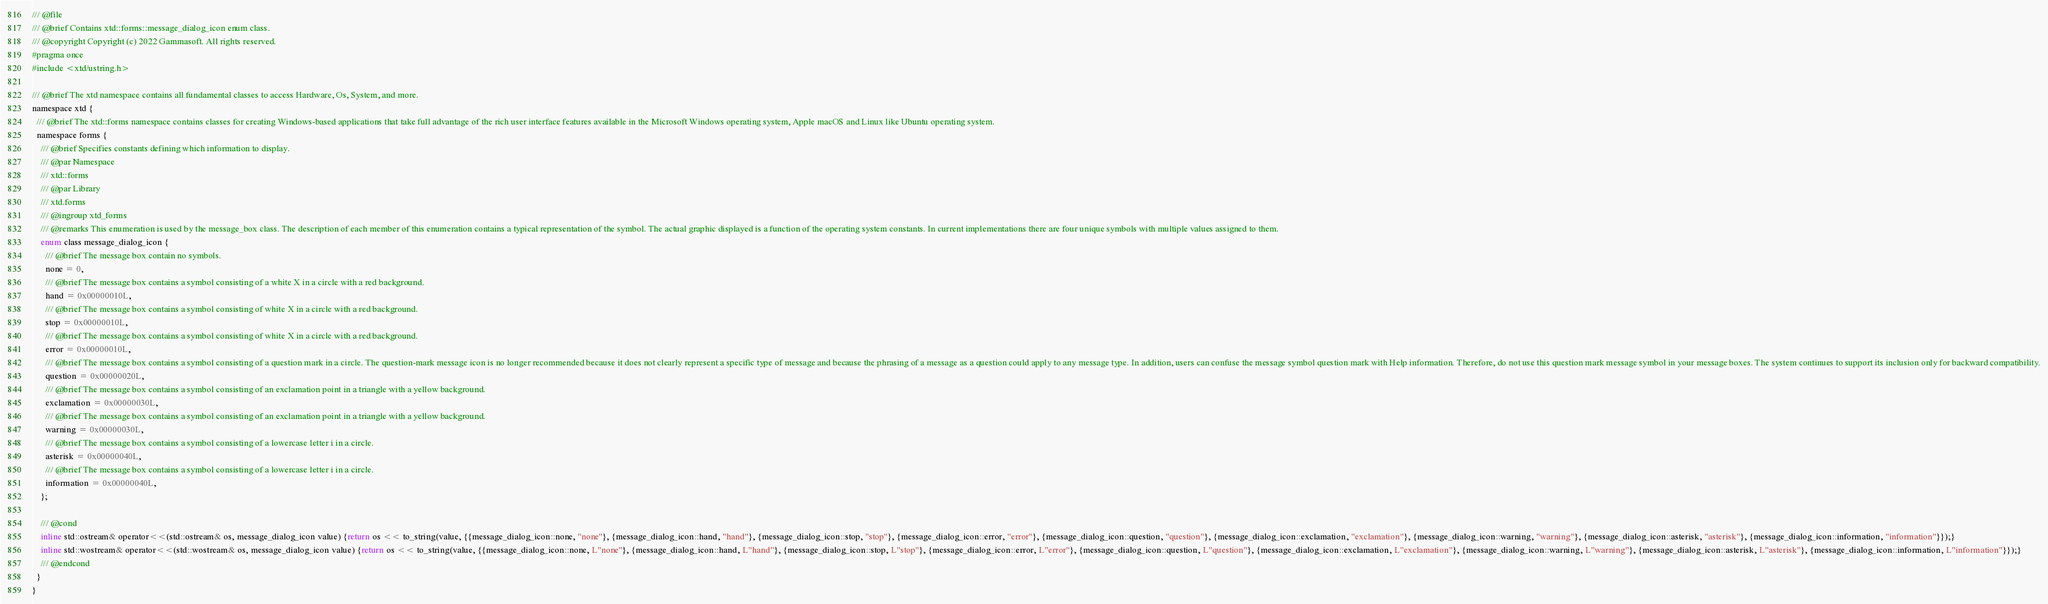<code> <loc_0><loc_0><loc_500><loc_500><_C_>/// @file
/// @brief Contains xtd::forms::message_dialog_icon enum class.
/// @copyright Copyright (c) 2022 Gammasoft. All rights reserved.
#pragma once
#include <xtd/ustring.h>

/// @brief The xtd namespace contains all fundamental classes to access Hardware, Os, System, and more.
namespace xtd {
  /// @brief The xtd::forms namespace contains classes for creating Windows-based applications that take full advantage of the rich user interface features available in the Microsoft Windows operating system, Apple macOS and Linux like Ubuntu operating system.
  namespace forms {
    /// @brief Specifies constants defining which information to display.
    /// @par Namespace
    /// xtd::forms
    /// @par Library
    /// xtd.forms
    /// @ingroup xtd_forms
    /// @remarks This enumeration is used by the message_box class. The description of each member of this enumeration contains a typical representation of the symbol. The actual graphic displayed is a function of the operating system constants. In current implementations there are four unique symbols with multiple values assigned to them.
    enum class message_dialog_icon {
      /// @brief The message box contain no symbols.
      none = 0,
      /// @brief The message box contains a symbol consisting of a white X in a circle with a red background.
      hand = 0x00000010L,
      /// @brief The message box contains a symbol consisting of white X in a circle with a red background.
      stop = 0x00000010L,
      /// @brief The message box contains a symbol consisting of white X in a circle with a red background.
      error = 0x00000010L,
      /// @brief The message box contains a symbol consisting of a question mark in a circle. The question-mark message icon is no longer recommended because it does not clearly represent a specific type of message and because the phrasing of a message as a question could apply to any message type. In addition, users can confuse the message symbol question mark with Help information. Therefore, do not use this question mark message symbol in your message boxes. The system continues to support its inclusion only for backward compatibility.
      question = 0x00000020L,
      /// @brief The message box contains a symbol consisting of an exclamation point in a triangle with a yellow background.
      exclamation = 0x00000030L,
      /// @brief The message box contains a symbol consisting of an exclamation point in a triangle with a yellow background.
      warning = 0x00000030L,
      /// @brief The message box contains a symbol consisting of a lowercase letter i in a circle.
      asterisk = 0x00000040L,
      /// @brief The message box contains a symbol consisting of a lowercase letter i in a circle.
      information = 0x00000040L,
    };
    
    /// @cond
    inline std::ostream& operator<<(std::ostream& os, message_dialog_icon value) {return os << to_string(value, {{message_dialog_icon::none, "none"}, {message_dialog_icon::hand, "hand"}, {message_dialog_icon::stop, "stop"}, {message_dialog_icon::error, "error"}, {message_dialog_icon::question, "question"}, {message_dialog_icon::exclamation, "exclamation"}, {message_dialog_icon::warning, "warning"}, {message_dialog_icon::asterisk, "asterisk"}, {message_dialog_icon::information, "information"}});}
    inline std::wostream& operator<<(std::wostream& os, message_dialog_icon value) {return os << to_string(value, {{message_dialog_icon::none, L"none"}, {message_dialog_icon::hand, L"hand"}, {message_dialog_icon::stop, L"stop"}, {message_dialog_icon::error, L"error"}, {message_dialog_icon::question, L"question"}, {message_dialog_icon::exclamation, L"exclamation"}, {message_dialog_icon::warning, L"warning"}, {message_dialog_icon::asterisk, L"asterisk"}, {message_dialog_icon::information, L"information"}});}
    /// @endcond
  }
}
</code> 